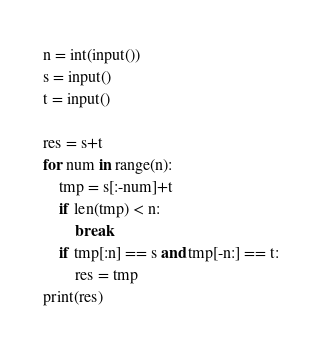Convert code to text. <code><loc_0><loc_0><loc_500><loc_500><_Python_>n = int(input())
s = input()
t = input()

res = s+t
for num in range(n):
    tmp = s[:-num]+t
    if len(tmp) < n:
        break
    if tmp[:n] == s and tmp[-n:] == t:
        res = tmp
print(res)
</code> 